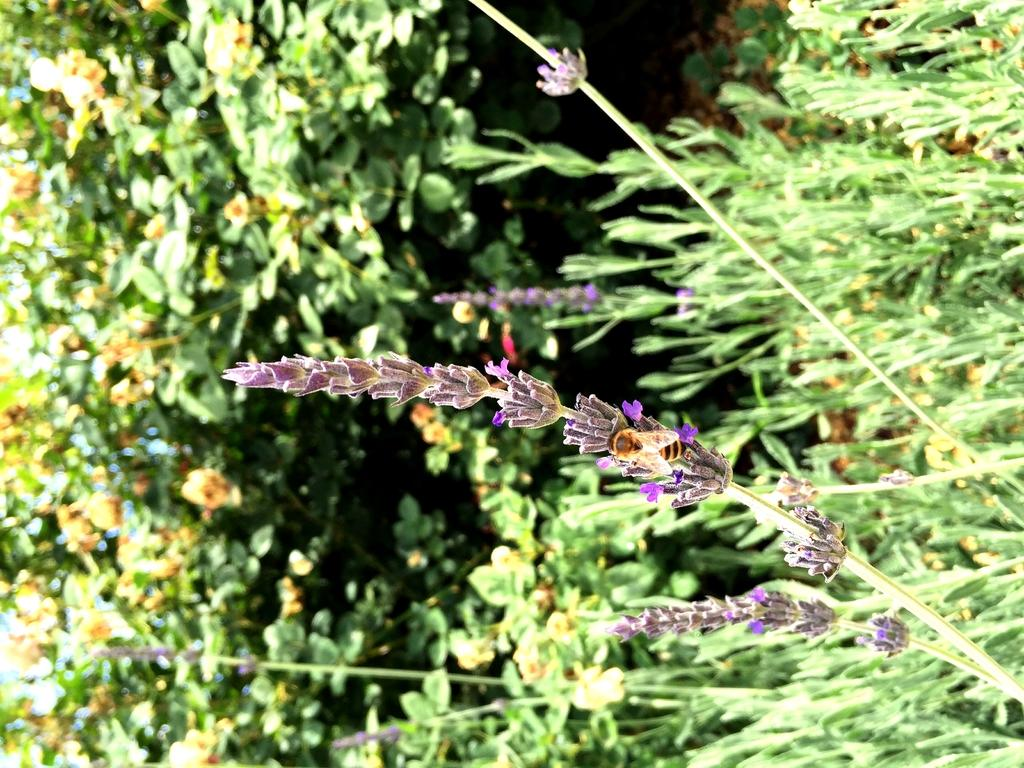What is on the flower in the image? There is an insect on a flower in the image. What can be seen in the background of the image? There are plants and trees in the background of the image. What type of drink is being served by the team in the image? There is no team or drink present in the image; it features an insect on a flower and plants and trees in the background. 